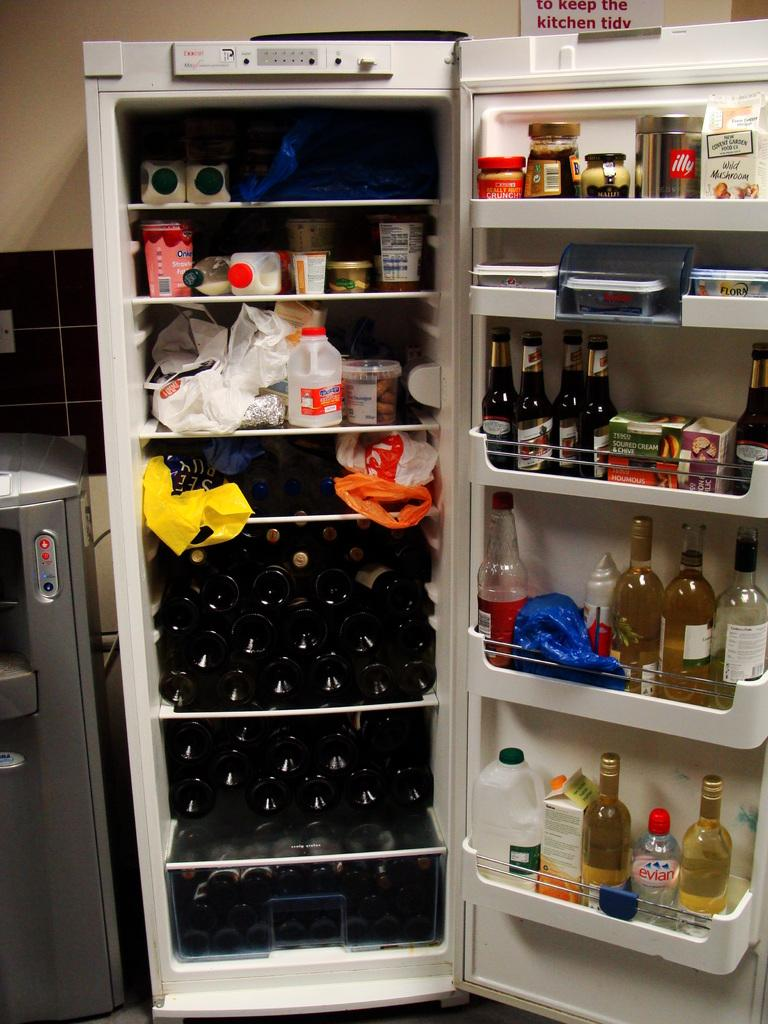<image>
Offer a succinct explanation of the picture presented. An Evian water bottle on the bottom shelf of the refrigerator is surrounded by two white wine bottles. 